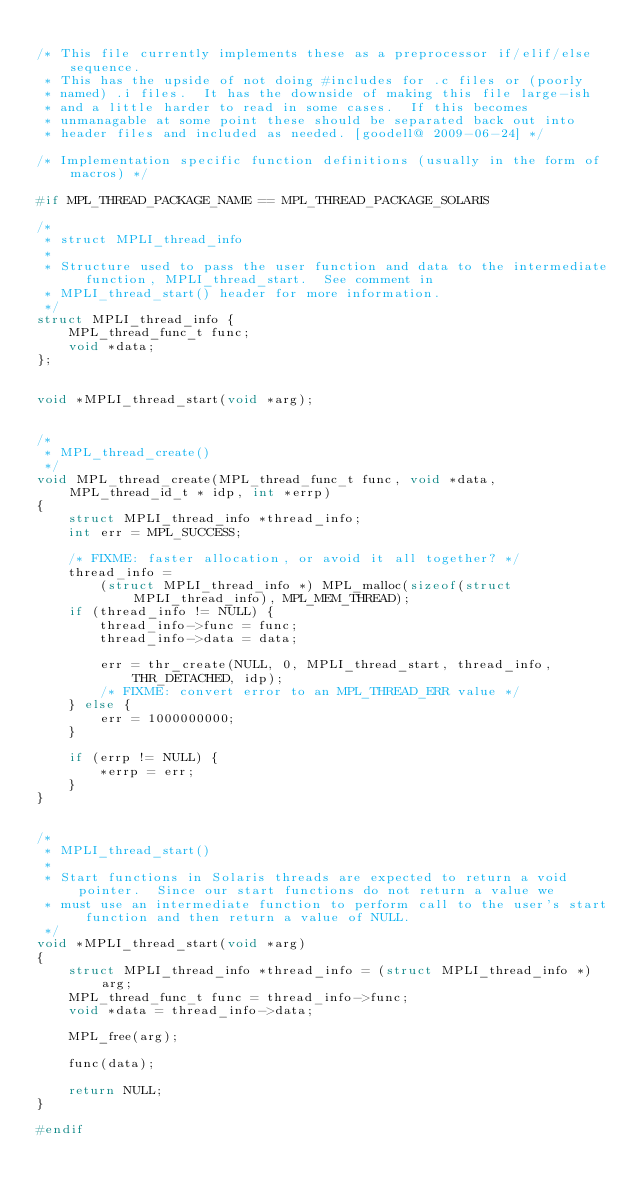<code> <loc_0><loc_0><loc_500><loc_500><_C_>
/* This file currently implements these as a preprocessor if/elif/else sequence.
 * This has the upside of not doing #includes for .c files or (poorly
 * named) .i files.  It has the downside of making this file large-ish
 * and a little harder to read in some cases.  If this becomes
 * unmanagable at some point these should be separated back out into
 * header files and included as needed. [goodell@ 2009-06-24] */

/* Implementation specific function definitions (usually in the form of macros) */

#if MPL_THREAD_PACKAGE_NAME == MPL_THREAD_PACKAGE_SOLARIS

/*
 * struct MPLI_thread_info
 *
 * Structure used to pass the user function and data to the intermediate function, MPLI_thread_start.  See comment in
 * MPLI_thread_start() header for more information.
 */
struct MPLI_thread_info {
    MPL_thread_func_t func;
    void *data;
};


void *MPLI_thread_start(void *arg);


/*
 * MPL_thread_create()
 */
void MPL_thread_create(MPL_thread_func_t func, void *data, MPL_thread_id_t * idp, int *errp)
{
    struct MPLI_thread_info *thread_info;
    int err = MPL_SUCCESS;

    /* FIXME: faster allocation, or avoid it all together? */
    thread_info =
        (struct MPLI_thread_info *) MPL_malloc(sizeof(struct MPLI_thread_info), MPL_MEM_THREAD);
    if (thread_info != NULL) {
        thread_info->func = func;
        thread_info->data = data;

        err = thr_create(NULL, 0, MPLI_thread_start, thread_info, THR_DETACHED, idp);
        /* FIXME: convert error to an MPL_THREAD_ERR value */
    } else {
        err = 1000000000;
    }

    if (errp != NULL) {
        *errp = err;
    }
}


/*
 * MPLI_thread_start()
 *
 * Start functions in Solaris threads are expected to return a void pointer.  Since our start functions do not return a value we
 * must use an intermediate function to perform call to the user's start function and then return a value of NULL.
 */
void *MPLI_thread_start(void *arg)
{
    struct MPLI_thread_info *thread_info = (struct MPLI_thread_info *) arg;
    MPL_thread_func_t func = thread_info->func;
    void *data = thread_info->data;

    MPL_free(arg);

    func(data);

    return NULL;
}

#endif
</code> 